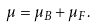<formula> <loc_0><loc_0><loc_500><loc_500>\mu = \mu _ { B } + \mu _ { F } .</formula> 